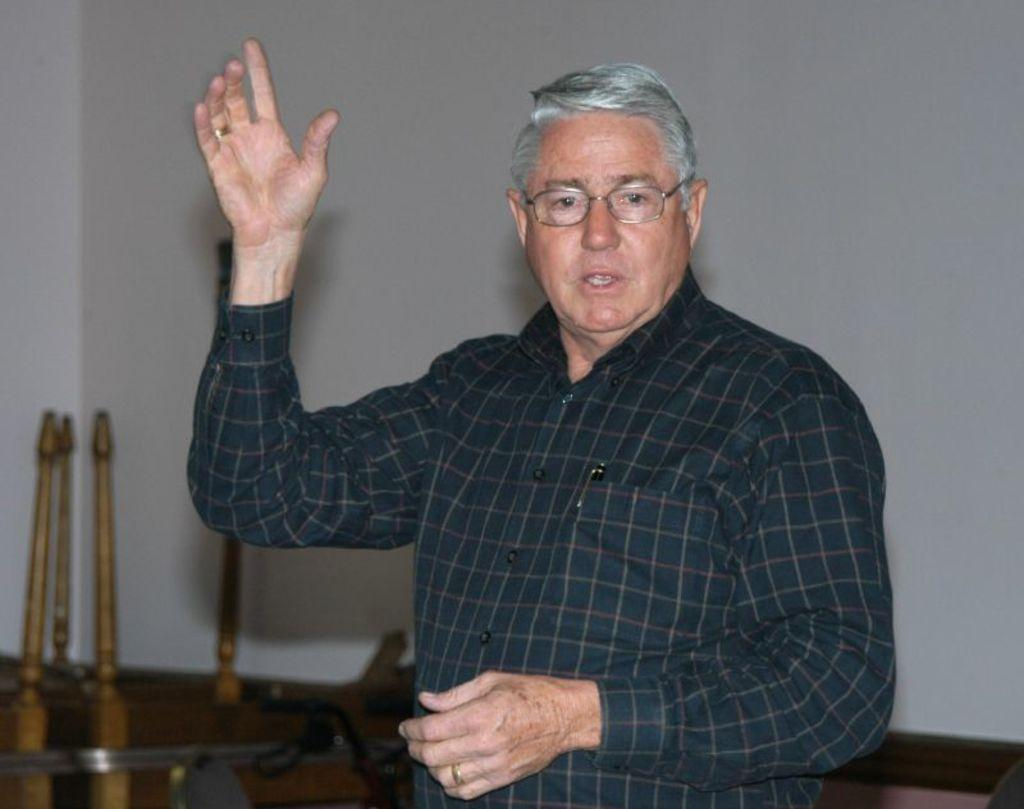Who or what is the main subject in the image? There is a person in the image. What is behind the person in the image? The person is in front of a wall. What is the person wearing? The person is wearing clothes and spectacles. Can you describe anything else in the image? There are sticks in the bottom left of the image. What type of tent can be seen in the image? There is no tent present in the image. Can you describe the ground in the image? The ground is not visible in the image, as the person is standing in front of a wall. 